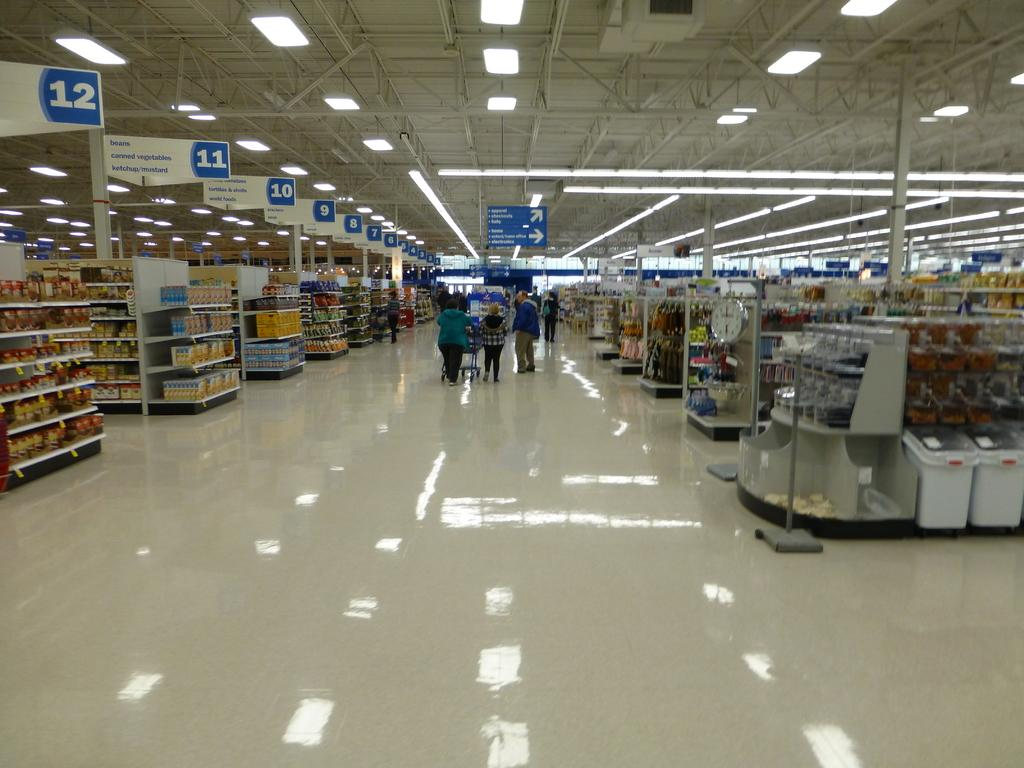<image>
Describe the image concisely. Empty store with a sign saying the apparel is to the right. 